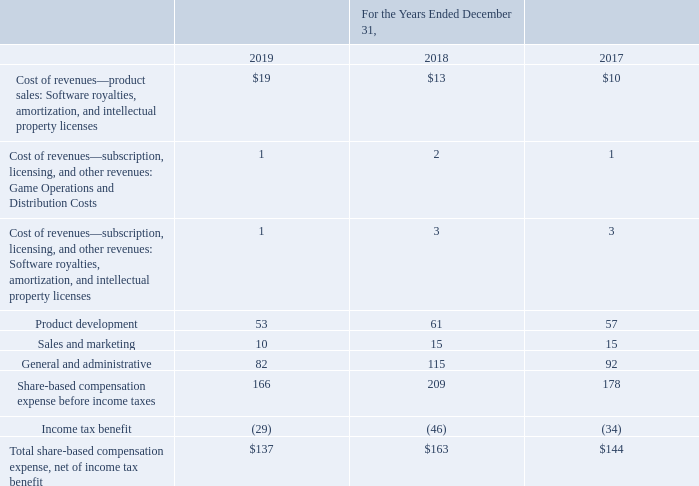Share-Based Compensation Expense
The following table sets forth the total share-based compensation expense included in our consolidated statements of operations (amounts in millions):
What was the cost of revenues from product sales in 2019?
Answer scale should be: million. $19. What was the cost of revenues from product sales in 2018?
Answer scale should be: million. $13. What was the sales and marketing in 2017?
Answer scale should be: million. 15. What was the change in sales and marketing between 2018 and 2019?
Answer scale should be: million. 10-15
Answer: -5. What was the change in product development between 2018 and 2019?
Answer scale should be: million. 53-61
Answer: -8. What was the percentage change in General and administrative expenses between 2017 and 2018?
Answer scale should be: percent. (115-92)/92
Answer: 25. 